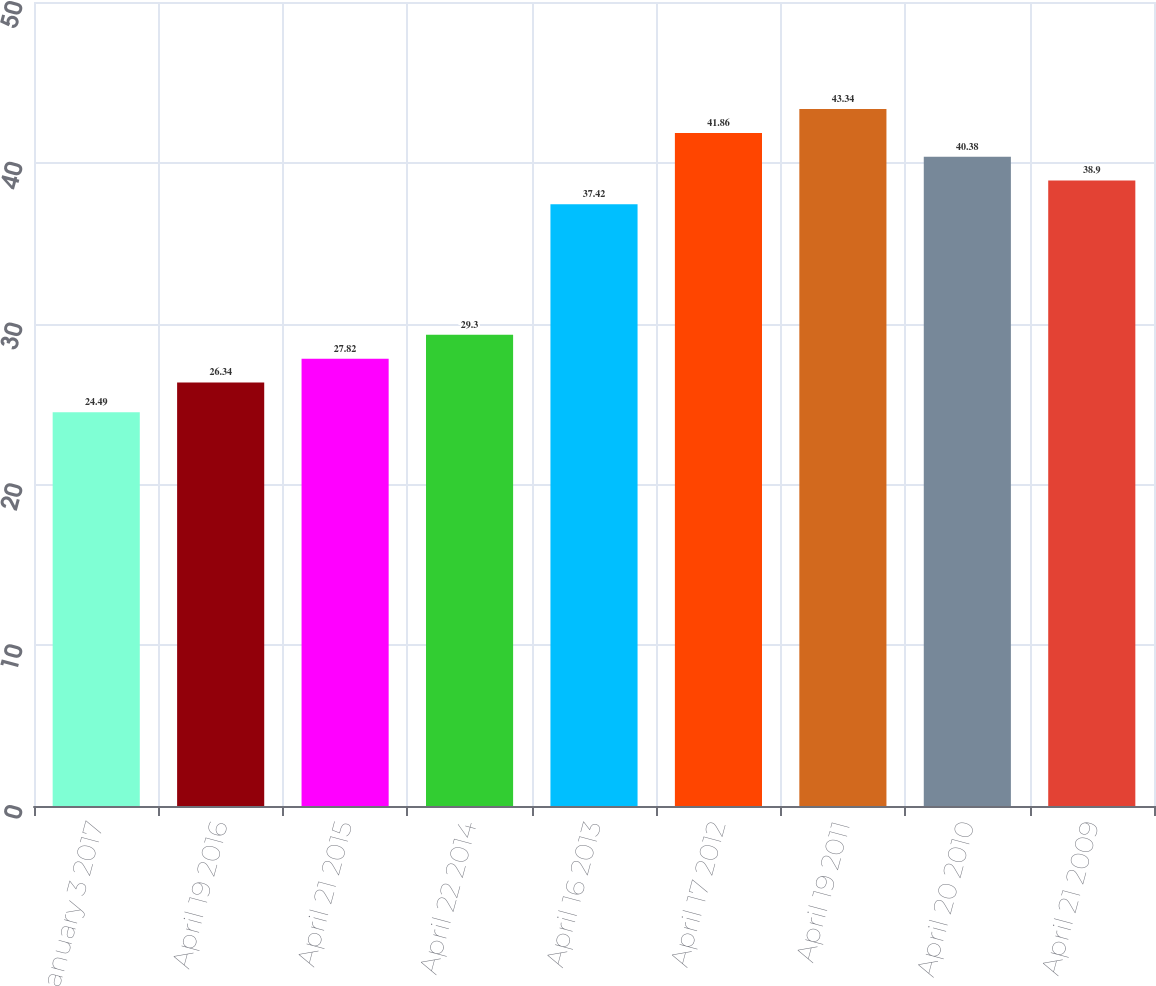Convert chart. <chart><loc_0><loc_0><loc_500><loc_500><bar_chart><fcel>January 3 2017<fcel>April 19 2016<fcel>April 21 2015<fcel>April 22 2014<fcel>April 16 2013<fcel>April 17 2012<fcel>April 19 2011<fcel>April 20 2010<fcel>April 21 2009<nl><fcel>24.49<fcel>26.34<fcel>27.82<fcel>29.3<fcel>37.42<fcel>41.86<fcel>43.34<fcel>40.38<fcel>38.9<nl></chart> 